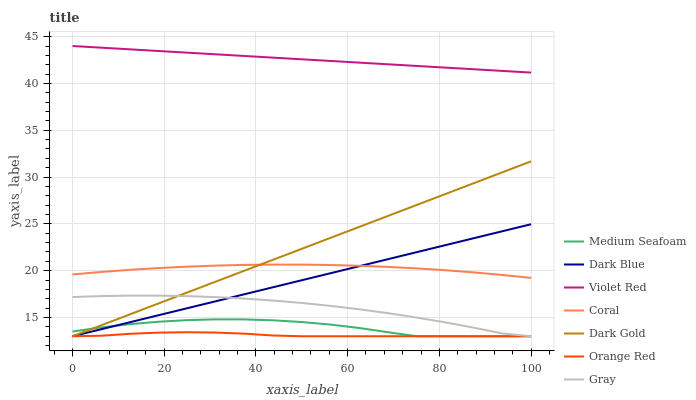Does Orange Red have the minimum area under the curve?
Answer yes or no. Yes. Does Violet Red have the maximum area under the curve?
Answer yes or no. Yes. Does Dark Gold have the minimum area under the curve?
Answer yes or no. No. Does Dark Gold have the maximum area under the curve?
Answer yes or no. No. Is Dark Blue the smoothest?
Answer yes or no. Yes. Is Medium Seafoam the roughest?
Answer yes or no. Yes. Is Violet Red the smoothest?
Answer yes or no. No. Is Violet Red the roughest?
Answer yes or no. No. Does Gray have the lowest value?
Answer yes or no. Yes. Does Violet Red have the lowest value?
Answer yes or no. No. Does Violet Red have the highest value?
Answer yes or no. Yes. Does Dark Gold have the highest value?
Answer yes or no. No. Is Orange Red less than Violet Red?
Answer yes or no. Yes. Is Violet Red greater than Coral?
Answer yes or no. Yes. Does Dark Blue intersect Medium Seafoam?
Answer yes or no. Yes. Is Dark Blue less than Medium Seafoam?
Answer yes or no. No. Is Dark Blue greater than Medium Seafoam?
Answer yes or no. No. Does Orange Red intersect Violet Red?
Answer yes or no. No. 